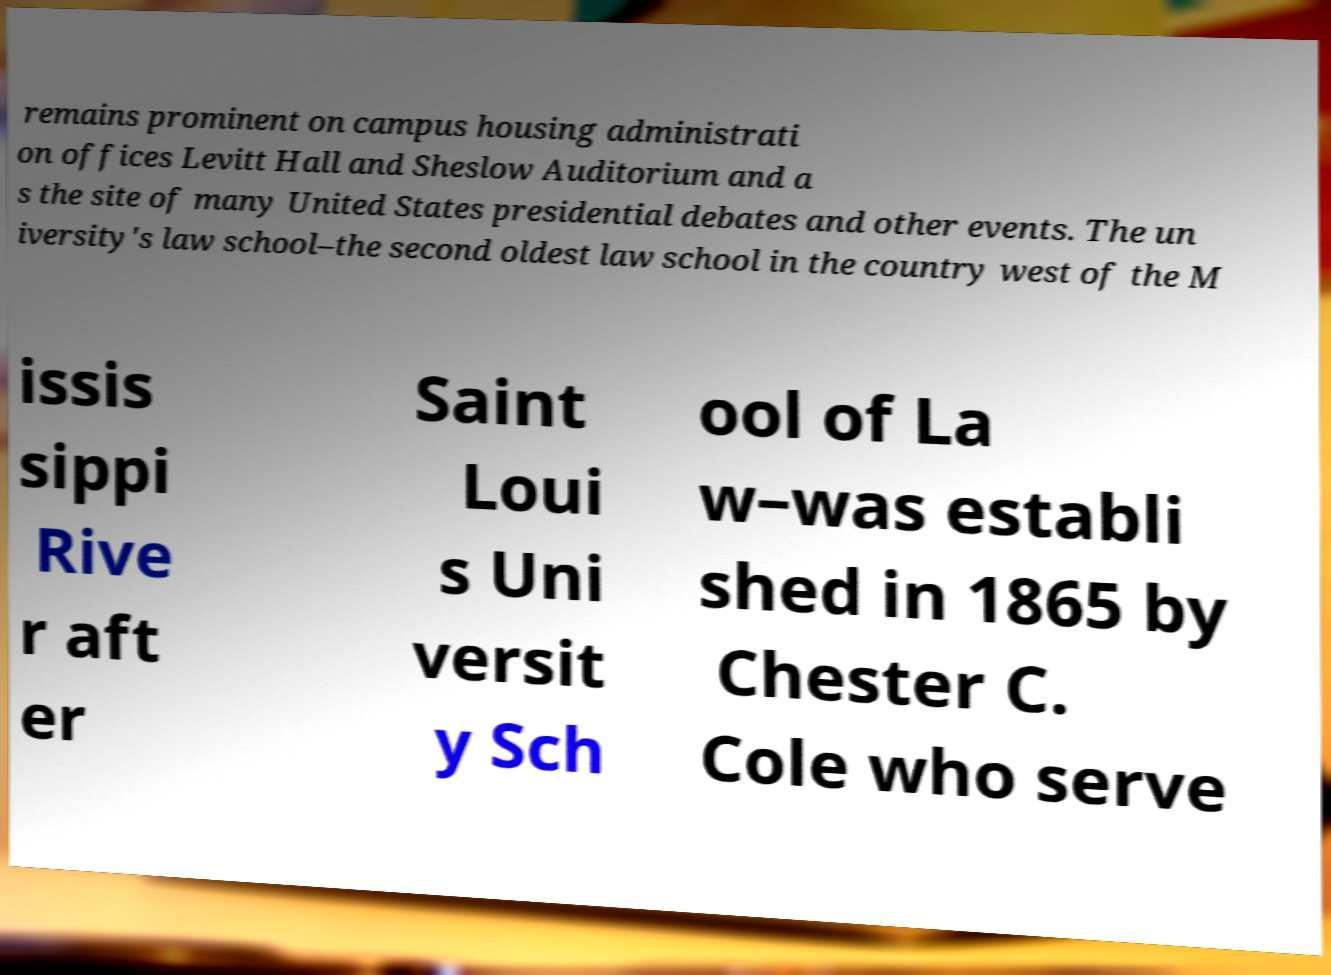Please read and relay the text visible in this image. What does it say? remains prominent on campus housing administrati on offices Levitt Hall and Sheslow Auditorium and a s the site of many United States presidential debates and other events. The un iversity's law school–the second oldest law school in the country west of the M issis sippi Rive r aft er Saint Loui s Uni versit y Sch ool of La w–was establi shed in 1865 by Chester C. Cole who serve 